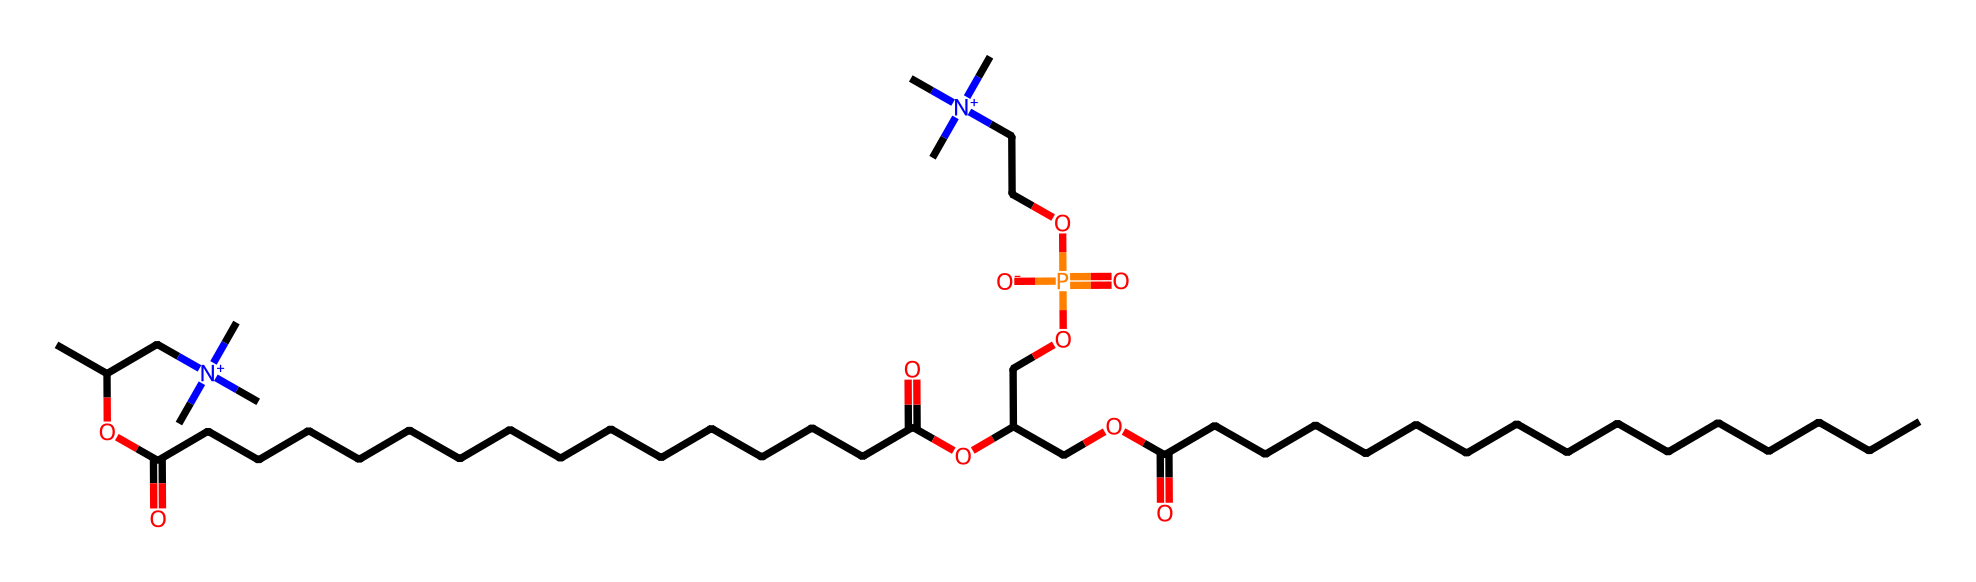What is the total number of phosphorus atoms in this compound? A careful look at the SMILES notation shows that there are two instances of the symbol "P", indicating that there are two phosphorus atoms present in the compound.
Answer: two How many ester bonds are present in this molecule? The SMILES representation shows two occurrences of "OC(=O)", indicating two ester functional groups in the structure, which confirms the presence of two ester bonds.
Answer: two What type of functional groups are prominently featured in this compound? By analyzing the SMILES, we can identify the presence of quaternary ammonium groups (indicated by the "[N+]" symbols) and ester groups (shown as "OC(=O)"). This indicates that the compound features quaternary ammonium and ester functional groups.
Answer: quaternary ammonium and ester Which part of the structure contributes to the hydrophilic nature of this phospholipid? The part of the structure that contains the phosphorus atom and the bound oxygen atoms (as seen in the phosphate group) is hydrophilic due to the presence of polar bonds. These characteristics contribute to the overall hydrophilic nature of phosphatidylcholine.
Answer: phosphate group How many carbon atoms are in this molecule? Counting all carbon (C) symbols in the SMILES string reveals a total of 30 carbon atoms present (including those in the chains and in the quaternary ammonium groups).
Answer: thirty What is the charge of the nitrogen atoms in this compound? The presence of "[N+]" in the SMILES indicates that the nitrogen atoms are positively charged, characterizing them as quaternary ammonium ions in this structure.
Answer: positive What role does this compound play in biological membranes? Phosphatidylcholine, indicated by its structure here, is a primary component of cell membranes, serving as a phospholipid that contributes to membrane fluidity and structure.
Answer: phospholipid 